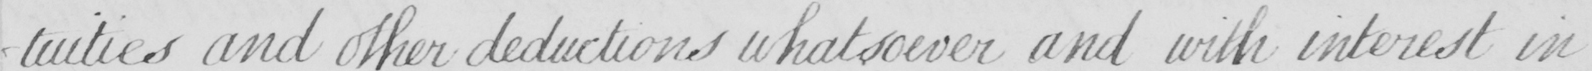Transcribe the text shown in this historical manuscript line. -tuities and other deductions whatsoever and with interest in 